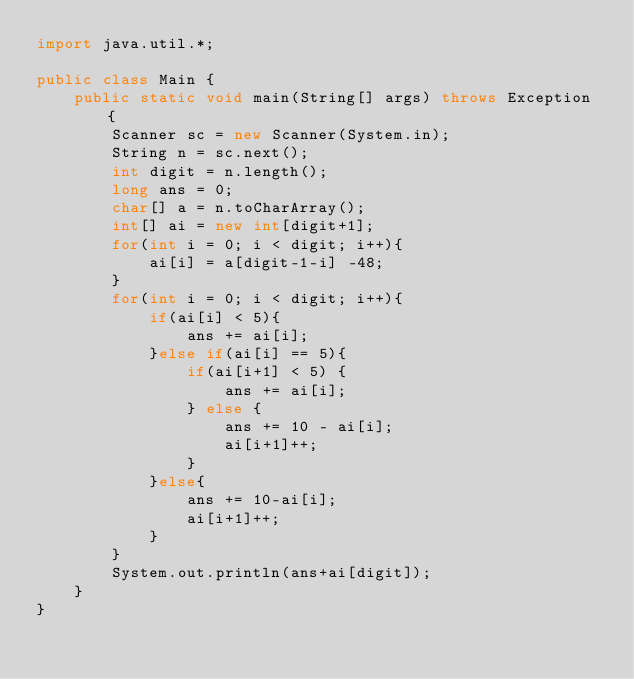Convert code to text. <code><loc_0><loc_0><loc_500><loc_500><_Java_>import java.util.*;
 
public class Main {
    public static void main(String[] args) throws Exception {
        Scanner sc = new Scanner(System.in);
        String n = sc.next();
        int digit = n.length();
        long ans = 0;
        char[] a = n.toCharArray();
        int[] ai = new int[digit+1];
        for(int i = 0; i < digit; i++){
            ai[i] = a[digit-1-i] -48;
        }
        for(int i = 0; i < digit; i++){
            if(ai[i] < 5){
                ans += ai[i];
            }else if(ai[i] == 5){
                if(ai[i+1] < 5) {
					ans += ai[i];
				} else {
					ans += 10 - ai[i];
					ai[i+1]++;
				}
            }else{
                ans += 10-ai[i];
                ai[i+1]++;
            }
        }
        System.out.println(ans+ai[digit]);
    }
}</code> 